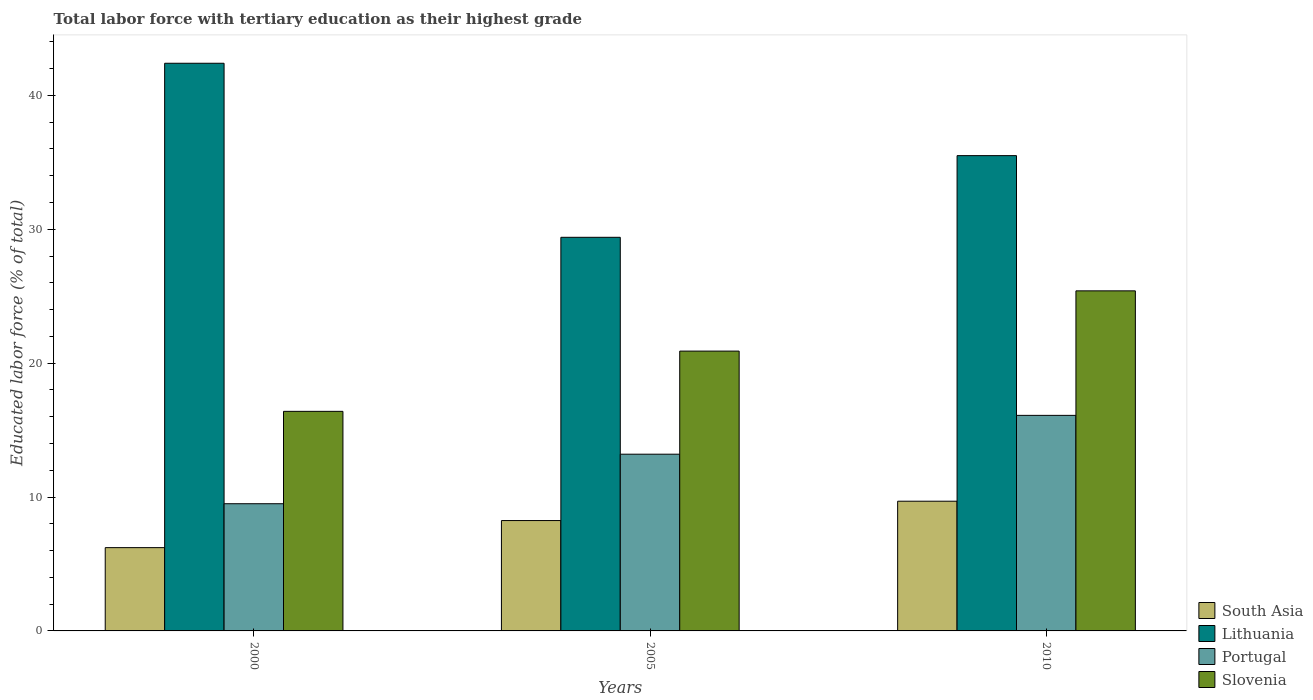How many different coloured bars are there?
Your response must be concise. 4. How many bars are there on the 1st tick from the left?
Offer a very short reply. 4. What is the label of the 2nd group of bars from the left?
Your answer should be very brief. 2005. What is the percentage of male labor force with tertiary education in Slovenia in 2005?
Offer a terse response. 20.9. Across all years, what is the maximum percentage of male labor force with tertiary education in Portugal?
Keep it short and to the point. 16.1. In which year was the percentage of male labor force with tertiary education in Portugal maximum?
Offer a very short reply. 2010. What is the total percentage of male labor force with tertiary education in Slovenia in the graph?
Your answer should be very brief. 62.7. What is the difference between the percentage of male labor force with tertiary education in Portugal in 2000 and that in 2005?
Offer a very short reply. -3.7. What is the difference between the percentage of male labor force with tertiary education in Slovenia in 2000 and the percentage of male labor force with tertiary education in Portugal in 2005?
Your response must be concise. 3.2. What is the average percentage of male labor force with tertiary education in South Asia per year?
Your response must be concise. 8.05. In the year 2005, what is the difference between the percentage of male labor force with tertiary education in South Asia and percentage of male labor force with tertiary education in Slovenia?
Make the answer very short. -12.66. What is the ratio of the percentage of male labor force with tertiary education in Lithuania in 2005 to that in 2010?
Ensure brevity in your answer.  0.83. Is the difference between the percentage of male labor force with tertiary education in South Asia in 2000 and 2005 greater than the difference between the percentage of male labor force with tertiary education in Slovenia in 2000 and 2005?
Make the answer very short. Yes. What is the difference between the highest and the second highest percentage of male labor force with tertiary education in South Asia?
Give a very brief answer. 1.45. What is the difference between the highest and the lowest percentage of male labor force with tertiary education in Portugal?
Your answer should be compact. 6.6. In how many years, is the percentage of male labor force with tertiary education in Slovenia greater than the average percentage of male labor force with tertiary education in Slovenia taken over all years?
Ensure brevity in your answer.  1. Is the sum of the percentage of male labor force with tertiary education in Portugal in 2000 and 2005 greater than the maximum percentage of male labor force with tertiary education in South Asia across all years?
Ensure brevity in your answer.  Yes. What does the 2nd bar from the left in 2005 represents?
Your answer should be very brief. Lithuania. How many bars are there?
Provide a short and direct response. 12. Are all the bars in the graph horizontal?
Provide a succinct answer. No. How many years are there in the graph?
Offer a terse response. 3. Are the values on the major ticks of Y-axis written in scientific E-notation?
Ensure brevity in your answer.  No. Does the graph contain grids?
Keep it short and to the point. No. Where does the legend appear in the graph?
Offer a terse response. Bottom right. How many legend labels are there?
Your answer should be very brief. 4. How are the legend labels stacked?
Keep it short and to the point. Vertical. What is the title of the graph?
Provide a succinct answer. Total labor force with tertiary education as their highest grade. What is the label or title of the Y-axis?
Provide a succinct answer. Educated labor force (% of total). What is the Educated labor force (% of total) of South Asia in 2000?
Provide a succinct answer. 6.22. What is the Educated labor force (% of total) of Lithuania in 2000?
Offer a terse response. 42.4. What is the Educated labor force (% of total) in Portugal in 2000?
Your response must be concise. 9.5. What is the Educated labor force (% of total) of Slovenia in 2000?
Ensure brevity in your answer.  16.4. What is the Educated labor force (% of total) of South Asia in 2005?
Your answer should be very brief. 8.24. What is the Educated labor force (% of total) in Lithuania in 2005?
Give a very brief answer. 29.4. What is the Educated labor force (% of total) in Portugal in 2005?
Offer a terse response. 13.2. What is the Educated labor force (% of total) of Slovenia in 2005?
Ensure brevity in your answer.  20.9. What is the Educated labor force (% of total) in South Asia in 2010?
Provide a short and direct response. 9.69. What is the Educated labor force (% of total) of Lithuania in 2010?
Your answer should be very brief. 35.5. What is the Educated labor force (% of total) of Portugal in 2010?
Provide a short and direct response. 16.1. What is the Educated labor force (% of total) of Slovenia in 2010?
Offer a terse response. 25.4. Across all years, what is the maximum Educated labor force (% of total) of South Asia?
Offer a very short reply. 9.69. Across all years, what is the maximum Educated labor force (% of total) of Lithuania?
Your answer should be very brief. 42.4. Across all years, what is the maximum Educated labor force (% of total) of Portugal?
Keep it short and to the point. 16.1. Across all years, what is the maximum Educated labor force (% of total) of Slovenia?
Your answer should be very brief. 25.4. Across all years, what is the minimum Educated labor force (% of total) in South Asia?
Ensure brevity in your answer.  6.22. Across all years, what is the minimum Educated labor force (% of total) of Lithuania?
Provide a short and direct response. 29.4. Across all years, what is the minimum Educated labor force (% of total) in Portugal?
Offer a very short reply. 9.5. Across all years, what is the minimum Educated labor force (% of total) of Slovenia?
Ensure brevity in your answer.  16.4. What is the total Educated labor force (% of total) of South Asia in the graph?
Provide a short and direct response. 24.15. What is the total Educated labor force (% of total) of Lithuania in the graph?
Give a very brief answer. 107.3. What is the total Educated labor force (% of total) of Portugal in the graph?
Ensure brevity in your answer.  38.8. What is the total Educated labor force (% of total) of Slovenia in the graph?
Offer a very short reply. 62.7. What is the difference between the Educated labor force (% of total) in South Asia in 2000 and that in 2005?
Keep it short and to the point. -2.02. What is the difference between the Educated labor force (% of total) of Lithuania in 2000 and that in 2005?
Offer a terse response. 13. What is the difference between the Educated labor force (% of total) of Portugal in 2000 and that in 2005?
Give a very brief answer. -3.7. What is the difference between the Educated labor force (% of total) of Slovenia in 2000 and that in 2005?
Offer a very short reply. -4.5. What is the difference between the Educated labor force (% of total) in South Asia in 2000 and that in 2010?
Your response must be concise. -3.47. What is the difference between the Educated labor force (% of total) of Lithuania in 2000 and that in 2010?
Keep it short and to the point. 6.9. What is the difference between the Educated labor force (% of total) in Slovenia in 2000 and that in 2010?
Keep it short and to the point. -9. What is the difference between the Educated labor force (% of total) in South Asia in 2005 and that in 2010?
Your answer should be compact. -1.45. What is the difference between the Educated labor force (% of total) of Slovenia in 2005 and that in 2010?
Ensure brevity in your answer.  -4.5. What is the difference between the Educated labor force (% of total) in South Asia in 2000 and the Educated labor force (% of total) in Lithuania in 2005?
Provide a short and direct response. -23.18. What is the difference between the Educated labor force (% of total) of South Asia in 2000 and the Educated labor force (% of total) of Portugal in 2005?
Make the answer very short. -6.98. What is the difference between the Educated labor force (% of total) in South Asia in 2000 and the Educated labor force (% of total) in Slovenia in 2005?
Provide a short and direct response. -14.68. What is the difference between the Educated labor force (% of total) in Lithuania in 2000 and the Educated labor force (% of total) in Portugal in 2005?
Your response must be concise. 29.2. What is the difference between the Educated labor force (% of total) in South Asia in 2000 and the Educated labor force (% of total) in Lithuania in 2010?
Offer a very short reply. -29.28. What is the difference between the Educated labor force (% of total) of South Asia in 2000 and the Educated labor force (% of total) of Portugal in 2010?
Your answer should be very brief. -9.88. What is the difference between the Educated labor force (% of total) of South Asia in 2000 and the Educated labor force (% of total) of Slovenia in 2010?
Your answer should be compact. -19.18. What is the difference between the Educated labor force (% of total) in Lithuania in 2000 and the Educated labor force (% of total) in Portugal in 2010?
Give a very brief answer. 26.3. What is the difference between the Educated labor force (% of total) of Lithuania in 2000 and the Educated labor force (% of total) of Slovenia in 2010?
Your answer should be compact. 17. What is the difference between the Educated labor force (% of total) of Portugal in 2000 and the Educated labor force (% of total) of Slovenia in 2010?
Your answer should be very brief. -15.9. What is the difference between the Educated labor force (% of total) of South Asia in 2005 and the Educated labor force (% of total) of Lithuania in 2010?
Provide a short and direct response. -27.26. What is the difference between the Educated labor force (% of total) of South Asia in 2005 and the Educated labor force (% of total) of Portugal in 2010?
Your answer should be compact. -7.86. What is the difference between the Educated labor force (% of total) of South Asia in 2005 and the Educated labor force (% of total) of Slovenia in 2010?
Your answer should be compact. -17.16. What is the difference between the Educated labor force (% of total) in Lithuania in 2005 and the Educated labor force (% of total) in Portugal in 2010?
Provide a short and direct response. 13.3. What is the average Educated labor force (% of total) in South Asia per year?
Your answer should be very brief. 8.05. What is the average Educated labor force (% of total) in Lithuania per year?
Your response must be concise. 35.77. What is the average Educated labor force (% of total) in Portugal per year?
Offer a very short reply. 12.93. What is the average Educated labor force (% of total) of Slovenia per year?
Provide a succinct answer. 20.9. In the year 2000, what is the difference between the Educated labor force (% of total) in South Asia and Educated labor force (% of total) in Lithuania?
Offer a terse response. -36.18. In the year 2000, what is the difference between the Educated labor force (% of total) of South Asia and Educated labor force (% of total) of Portugal?
Give a very brief answer. -3.28. In the year 2000, what is the difference between the Educated labor force (% of total) of South Asia and Educated labor force (% of total) of Slovenia?
Your answer should be very brief. -10.18. In the year 2000, what is the difference between the Educated labor force (% of total) in Lithuania and Educated labor force (% of total) in Portugal?
Give a very brief answer. 32.9. In the year 2000, what is the difference between the Educated labor force (% of total) of Portugal and Educated labor force (% of total) of Slovenia?
Ensure brevity in your answer.  -6.9. In the year 2005, what is the difference between the Educated labor force (% of total) of South Asia and Educated labor force (% of total) of Lithuania?
Ensure brevity in your answer.  -21.16. In the year 2005, what is the difference between the Educated labor force (% of total) of South Asia and Educated labor force (% of total) of Portugal?
Provide a short and direct response. -4.96. In the year 2005, what is the difference between the Educated labor force (% of total) in South Asia and Educated labor force (% of total) in Slovenia?
Provide a succinct answer. -12.66. In the year 2005, what is the difference between the Educated labor force (% of total) in Lithuania and Educated labor force (% of total) in Slovenia?
Offer a very short reply. 8.5. In the year 2010, what is the difference between the Educated labor force (% of total) in South Asia and Educated labor force (% of total) in Lithuania?
Your response must be concise. -25.81. In the year 2010, what is the difference between the Educated labor force (% of total) of South Asia and Educated labor force (% of total) of Portugal?
Offer a very short reply. -6.41. In the year 2010, what is the difference between the Educated labor force (% of total) in South Asia and Educated labor force (% of total) in Slovenia?
Make the answer very short. -15.71. In the year 2010, what is the difference between the Educated labor force (% of total) of Lithuania and Educated labor force (% of total) of Portugal?
Give a very brief answer. 19.4. In the year 2010, what is the difference between the Educated labor force (% of total) of Lithuania and Educated labor force (% of total) of Slovenia?
Keep it short and to the point. 10.1. What is the ratio of the Educated labor force (% of total) of South Asia in 2000 to that in 2005?
Ensure brevity in your answer.  0.75. What is the ratio of the Educated labor force (% of total) of Lithuania in 2000 to that in 2005?
Your response must be concise. 1.44. What is the ratio of the Educated labor force (% of total) of Portugal in 2000 to that in 2005?
Ensure brevity in your answer.  0.72. What is the ratio of the Educated labor force (% of total) in Slovenia in 2000 to that in 2005?
Provide a short and direct response. 0.78. What is the ratio of the Educated labor force (% of total) of South Asia in 2000 to that in 2010?
Ensure brevity in your answer.  0.64. What is the ratio of the Educated labor force (% of total) of Lithuania in 2000 to that in 2010?
Your response must be concise. 1.19. What is the ratio of the Educated labor force (% of total) of Portugal in 2000 to that in 2010?
Provide a short and direct response. 0.59. What is the ratio of the Educated labor force (% of total) in Slovenia in 2000 to that in 2010?
Your response must be concise. 0.65. What is the ratio of the Educated labor force (% of total) in South Asia in 2005 to that in 2010?
Offer a very short reply. 0.85. What is the ratio of the Educated labor force (% of total) in Lithuania in 2005 to that in 2010?
Your response must be concise. 0.83. What is the ratio of the Educated labor force (% of total) in Portugal in 2005 to that in 2010?
Offer a terse response. 0.82. What is the ratio of the Educated labor force (% of total) in Slovenia in 2005 to that in 2010?
Keep it short and to the point. 0.82. What is the difference between the highest and the second highest Educated labor force (% of total) of South Asia?
Offer a terse response. 1.45. What is the difference between the highest and the second highest Educated labor force (% of total) of Portugal?
Provide a succinct answer. 2.9. What is the difference between the highest and the lowest Educated labor force (% of total) of South Asia?
Give a very brief answer. 3.47. What is the difference between the highest and the lowest Educated labor force (% of total) in Slovenia?
Make the answer very short. 9. 